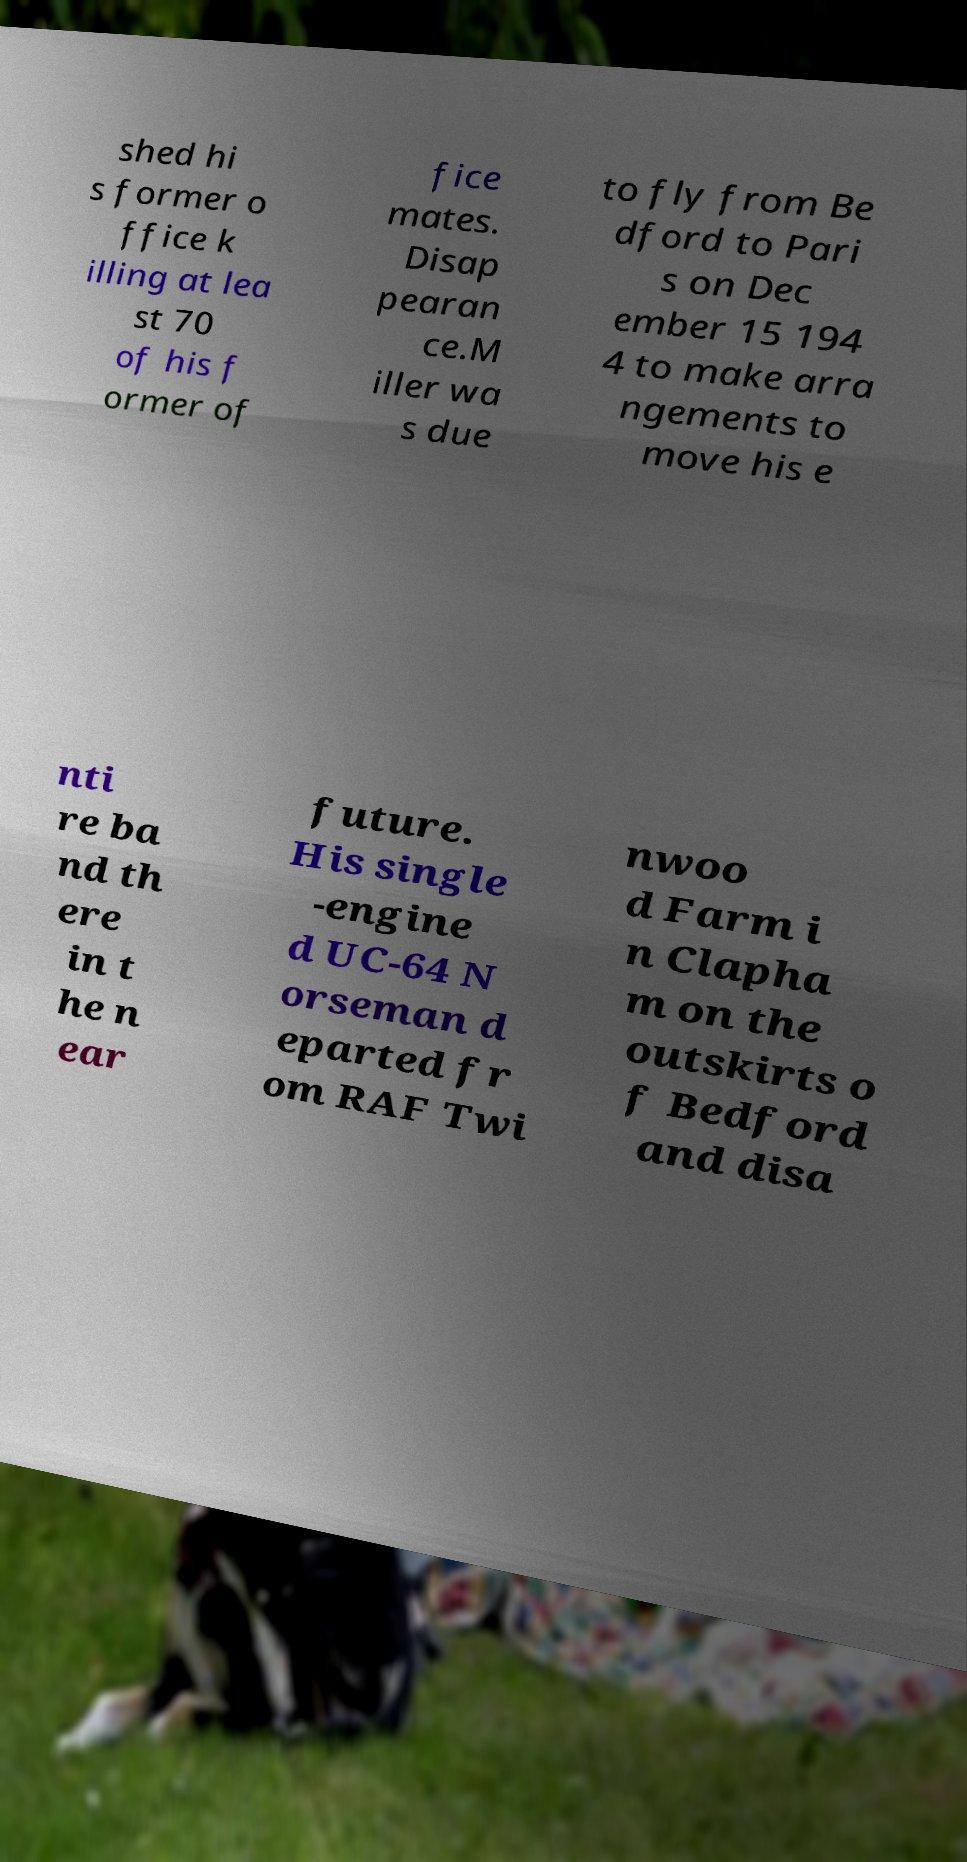I need the written content from this picture converted into text. Can you do that? shed hi s former o ffice k illing at lea st 70 of his f ormer of fice mates. Disap pearan ce.M iller wa s due to fly from Be dford to Pari s on Dec ember 15 194 4 to make arra ngements to move his e nti re ba nd th ere in t he n ear future. His single -engine d UC-64 N orseman d eparted fr om RAF Twi nwoo d Farm i n Clapha m on the outskirts o f Bedford and disa 